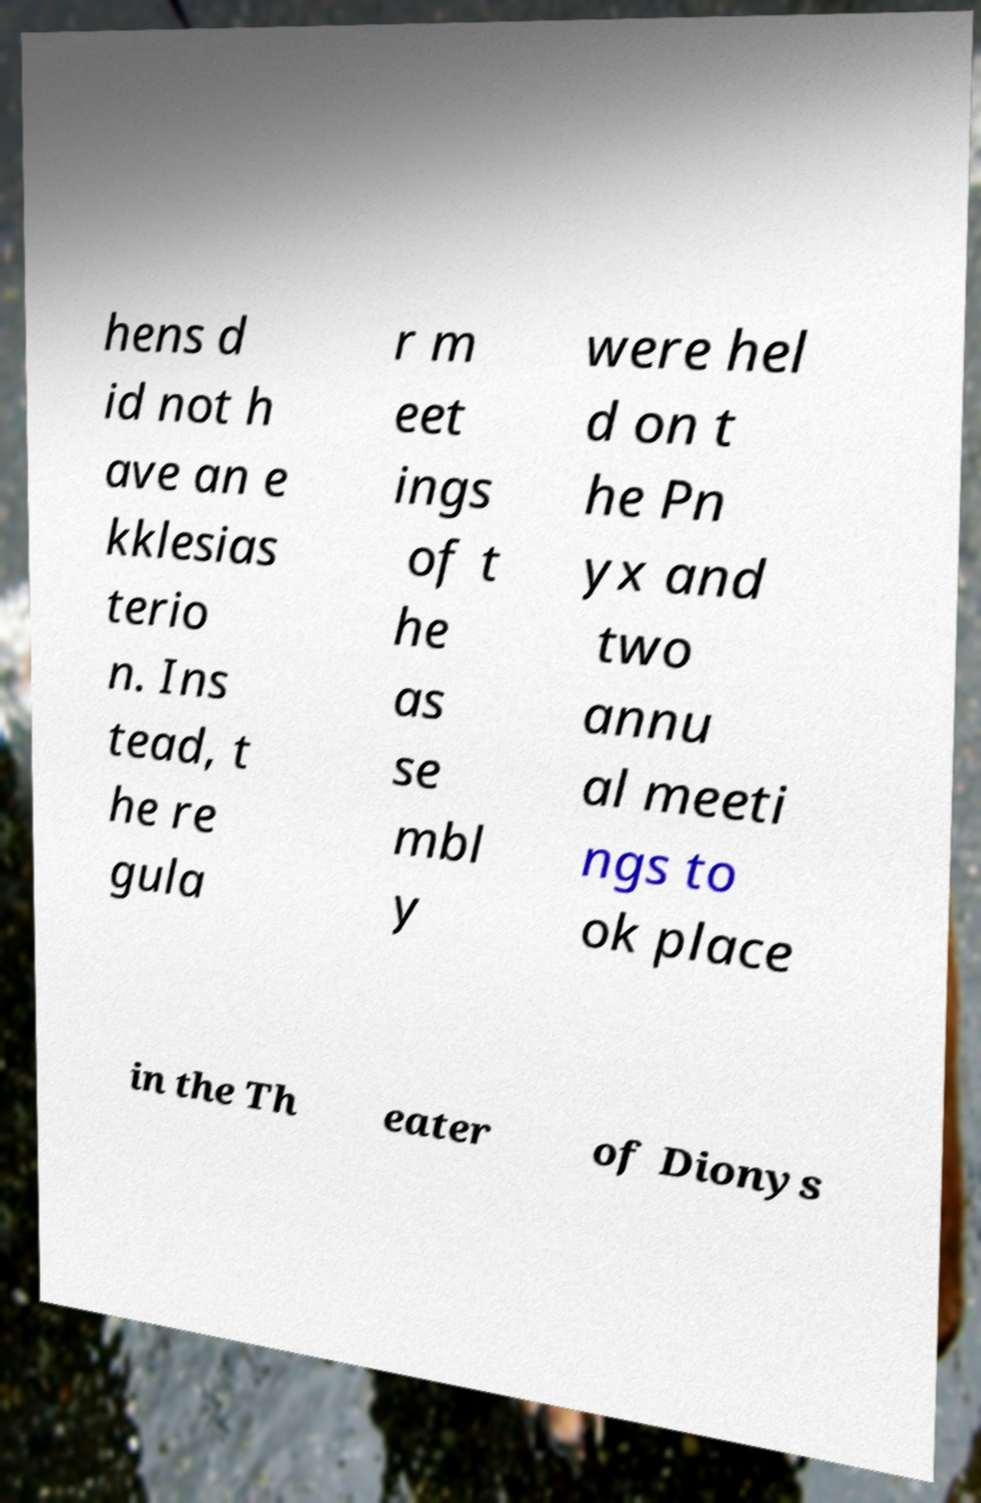Please identify and transcribe the text found in this image. hens d id not h ave an e kklesias terio n. Ins tead, t he re gula r m eet ings of t he as se mbl y were hel d on t he Pn yx and two annu al meeti ngs to ok place in the Th eater of Dionys 